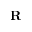<formula> <loc_0><loc_0><loc_500><loc_500>R</formula> 